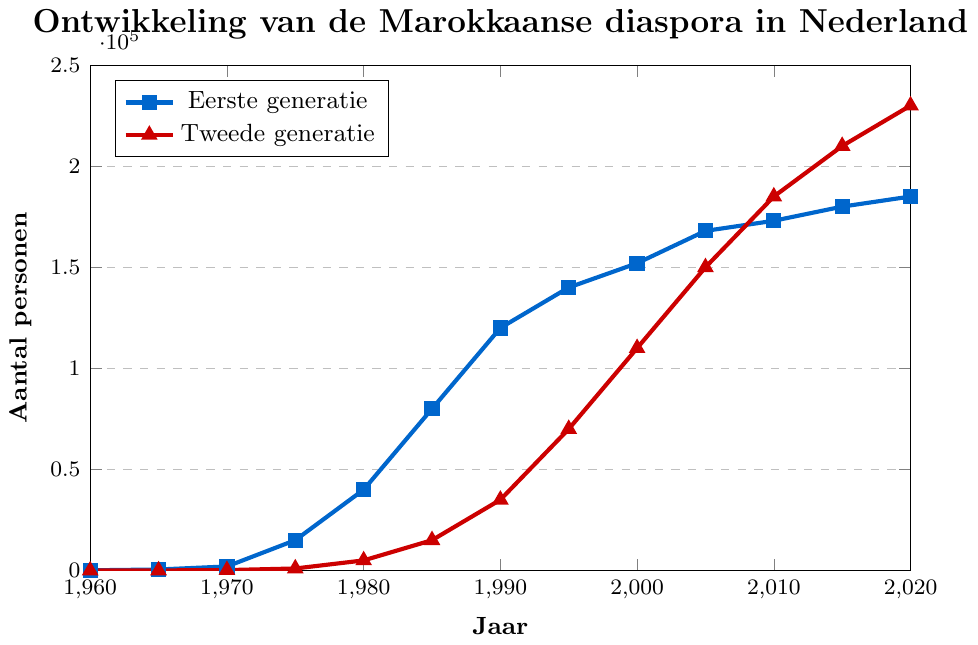Wat is het verschil in aantal personen tussen de eerste en tweede generatie in 1980? Kijk naar de waarde voor het jaar 1980. Eerste generatie is 40.000 en tweede generatie is 5.000. Het verschil is 40.000 - 5.000 = 35.000
Answer: 35.000 In welk jaar was het aantal personen van de tweede generatie gelijk aan het aantal personen van de eerste generatie? Kijk naar de snijpunten van de lijnen van de eerste en tweede generatie. In 2010 zijn beide 185.000 personen
Answer: 2010 Hoeveel meer personen waren er in 2020 vergeleken met 1960 voor de tweede generatie? In 2020 was het aantal 230.000 en in 1960 was het aantal 0. Het verschil is 230.000 - 0 = 230.000
Answer: 230.000 Welke generatie had een snellere groei tussen 1995 en 2005? Voor Eerste generatie: 168.000 - 140.000 = 28.000. Voor Tweede generatie: 150.000 - 70.000 = 80.000. De tweede generatie groeide sneller
Answer: Tweede generatie Wat is het gemeenschappelijke patroon in de groei van beide generaties vanaf 1960 tot 2020? Beide lijnen tonen een algemene stijgende trend van 1960 tot 2020, zonder enige significante daling
Answer: Stijgende trend In welk jaar overschreed de tweede generatie voor het eerst de 100.000 personen? Kijk naar het jaar in de lijn van de tweede generatie. Dit gebeurde in 2000 met 110.000 personen
Answer: 2000 Wat is het gemiddelde aantal personen voor de eerste generatie tussen 1960 en 2000? Som van (100 + 500 + 2000 + 15000 + 40000 + 80000 + 120000 + 140000 + 152000) = 569600 en deel dit door 9. Gemiddelde = 569600 / 9 ≈ 63.289
Answer: 63.289 Wat is het visuele verschil tussen de markeringen van de eerste en tweede generatie? De eerste generatie wordt weergegeven met vierkante markeringen en blauwe lijn, terwijl de tweede generatie met driehoekige markeringen en rode lijn wordt weergegeven
Answer: Kleuren en markeringen Welke generatie had halverwege de jaren 90 meer dan 100.000 personen? Kijk naar de figuur rond halverwege de jaren 90. Alleen de eerste generatie had meer dan 100.000 personen rond 1995 (140.000)
Answer: Eerste generatie 